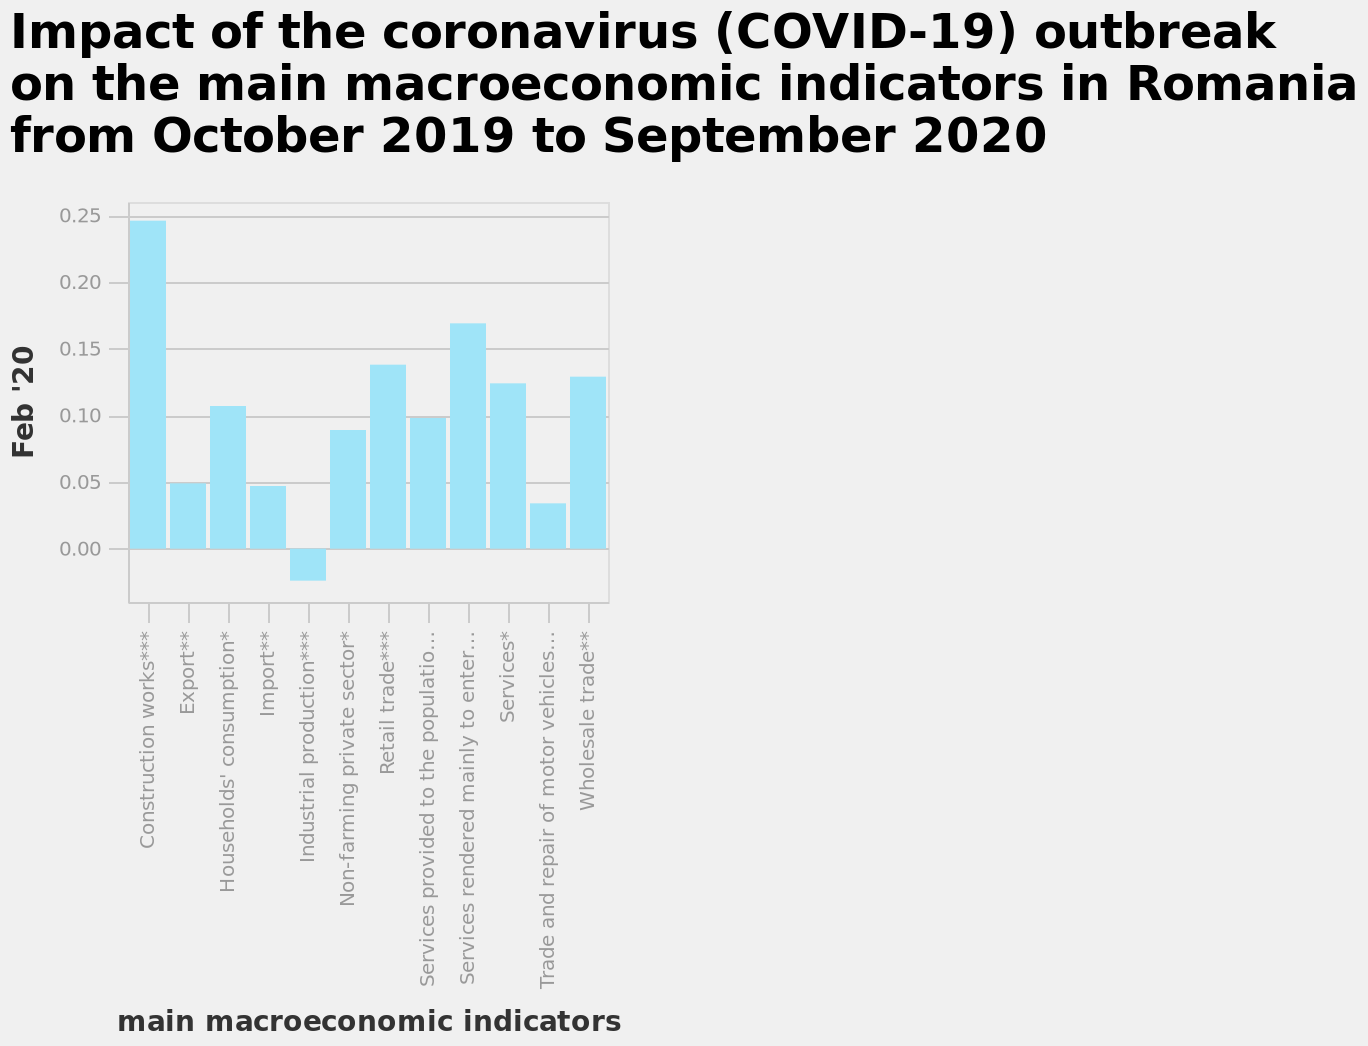<image>
What was the least impacted sector due to COVID-19? The industrial production sector was the least impacted due to COVID-19. Which sector experienced the least impact due to COVID-19?  The industrial production sector experienced the least impact due to COVID-19. 